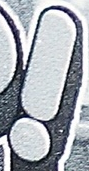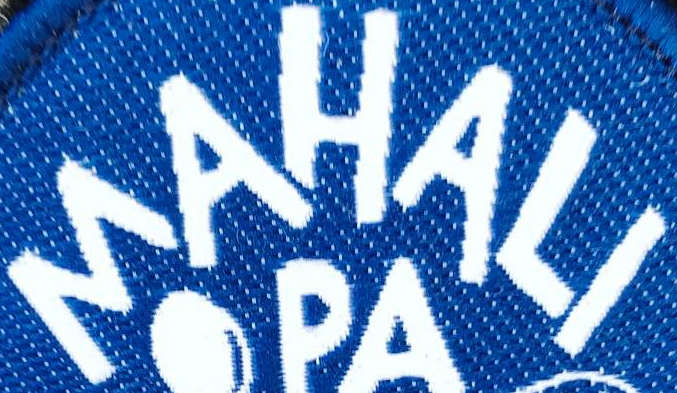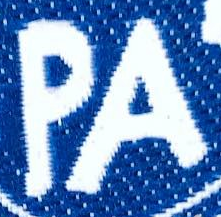What words can you see in these images in sequence, separated by a semicolon? !; MAHALI; PA 